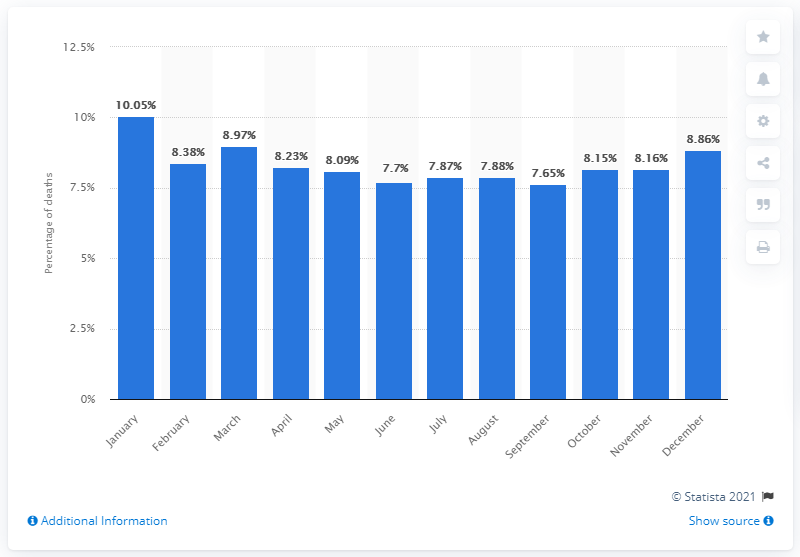Highlight a few significant elements in this photo. In January of the current year, approximately 10.05% of all deaths in the United States occurred. The most people died in the United States in 2013 in January. 